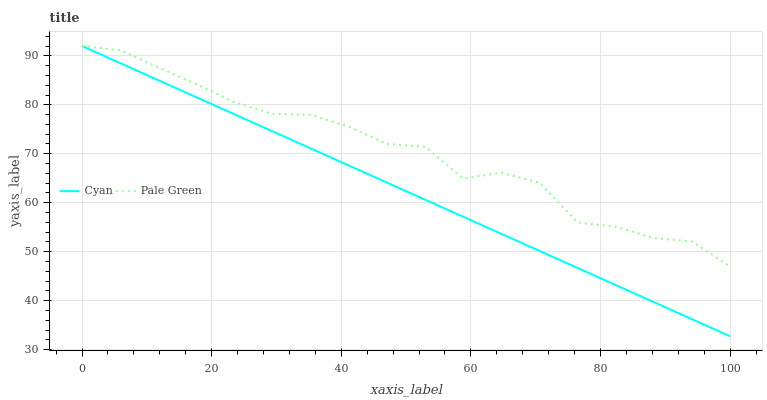Does Cyan have the minimum area under the curve?
Answer yes or no. Yes. Does Pale Green have the maximum area under the curve?
Answer yes or no. Yes. Does Pale Green have the minimum area under the curve?
Answer yes or no. No. Is Cyan the smoothest?
Answer yes or no. Yes. Is Pale Green the roughest?
Answer yes or no. Yes. Is Pale Green the smoothest?
Answer yes or no. No. Does Cyan have the lowest value?
Answer yes or no. Yes. Does Pale Green have the lowest value?
Answer yes or no. No. Does Pale Green have the highest value?
Answer yes or no. Yes. Does Pale Green intersect Cyan?
Answer yes or no. Yes. Is Pale Green less than Cyan?
Answer yes or no. No. Is Pale Green greater than Cyan?
Answer yes or no. No. 